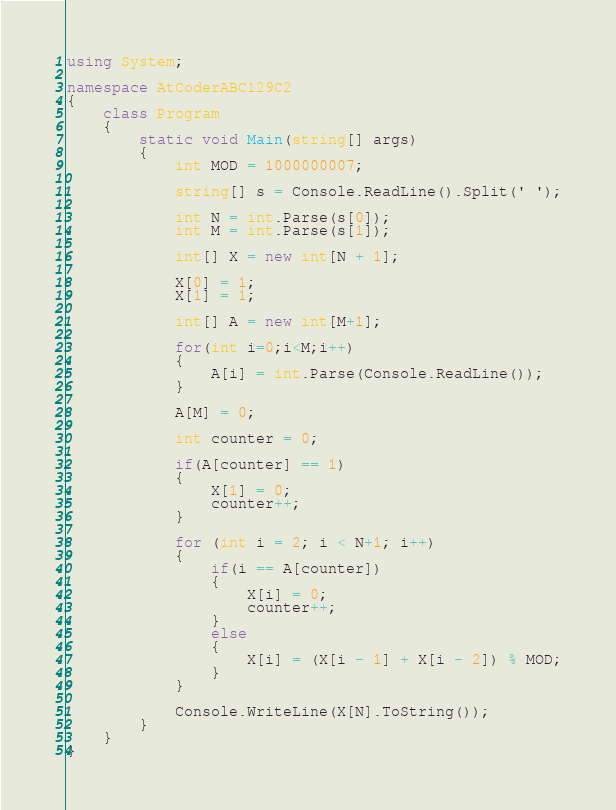<code> <loc_0><loc_0><loc_500><loc_500><_C#_>using System;

namespace AtCoderABC129C2
{
    class Program
    {
        static void Main(string[] args)
        {
            int MOD = 1000000007;

            string[] s = Console.ReadLine().Split(' ');

            int N = int.Parse(s[0]);
            int M = int.Parse(s[1]);

            int[] X = new int[N + 1];

            X[0] = 1;
            X[1] = 1;

            int[] A = new int[M+1];

            for(int i=0;i<M;i++)
            {
                A[i] = int.Parse(Console.ReadLine());
            }

            A[M] = 0;

            int counter = 0;

            if(A[counter] == 1)
            {
                X[1] = 0;
                counter++;
            }

            for (int i = 2; i < N+1; i++)
            {
                if(i == A[counter])
                {
                    X[i] = 0;
                    counter++;
                }
                else
                {
                    X[i] = (X[i - 1] + X[i - 2]) % MOD;
                }
            }

            Console.WriteLine(X[N].ToString());
        }
    }
}
</code> 